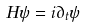<formula> <loc_0><loc_0><loc_500><loc_500>H \psi & = i { \partial } _ { t } \psi</formula> 